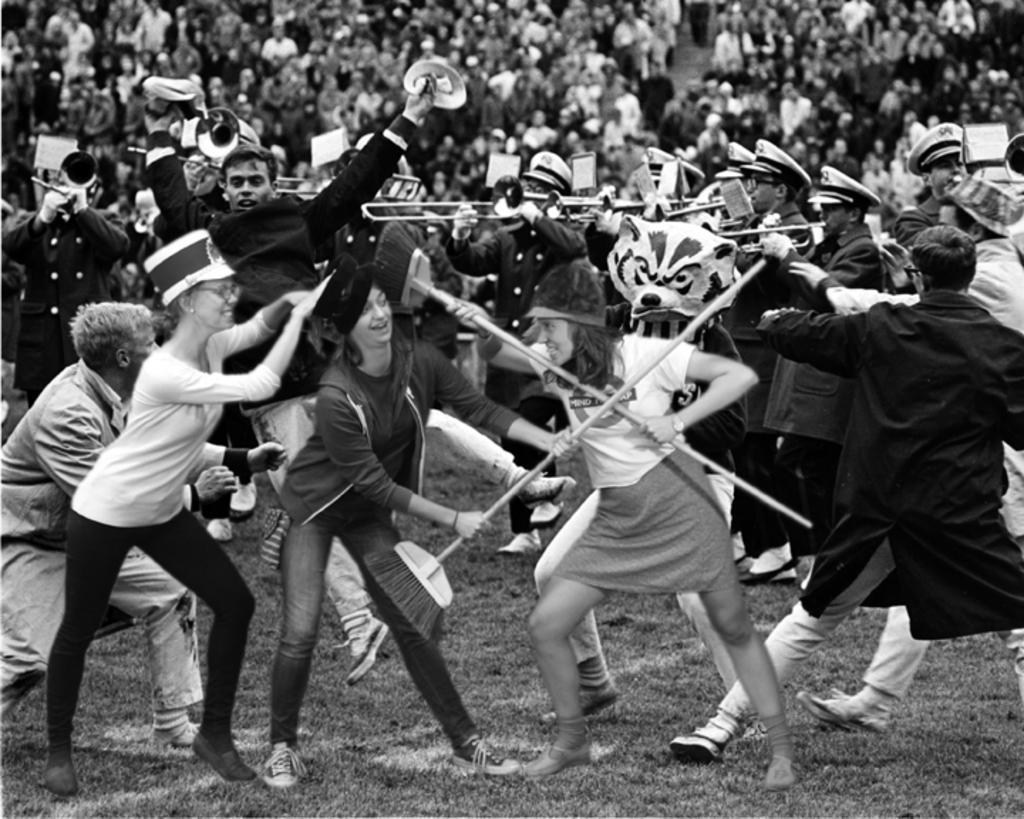Describe this image in one or two sentences. This is a black and white image. In the center of the image there are people playing musical instruments. In the background of the image there are many people. In the foreground of the image there are three ladies. At the bottom of the image there is grass. 